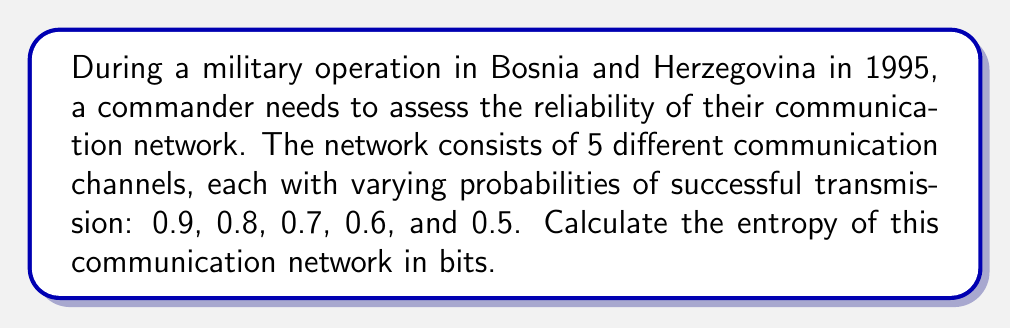Could you help me with this problem? To solve this problem, we'll use the concept of information entropy from statistical mechanics. The entropy of a system with discrete probabilities is given by the formula:

$$S = -k\sum_{i=1}^n p_i \log_2(p_i)$$

Where:
- $S$ is the entropy
- $k$ is Boltzmann's constant (in this case, we'll use $k=1$ as we're measuring in bits)
- $p_i$ is the probability of each state
- $n$ is the number of states

Steps:
1) We have 5 channels with probabilities: 0.9, 0.8, 0.7, 0.6, and 0.5

2) Calculate each term in the sum:
   - $-0.9 \log_2(0.9) = 0.1368$
   - $-0.8 \log_2(0.8) = 0.2575$
   - $-0.7 \log_2(0.7) = 0.3600$
   - $-0.6 \log_2(0.6) = 0.4422$
   - $-0.5 \log_2(0.5) = 0.5000$

3) Sum all terms:
   $S = 0.1368 + 0.2575 + 0.3600 + 0.4422 + 0.5000 = 1.6965$

Therefore, the entropy of the communication network is approximately 1.6965 bits.
Answer: 1.6965 bits 